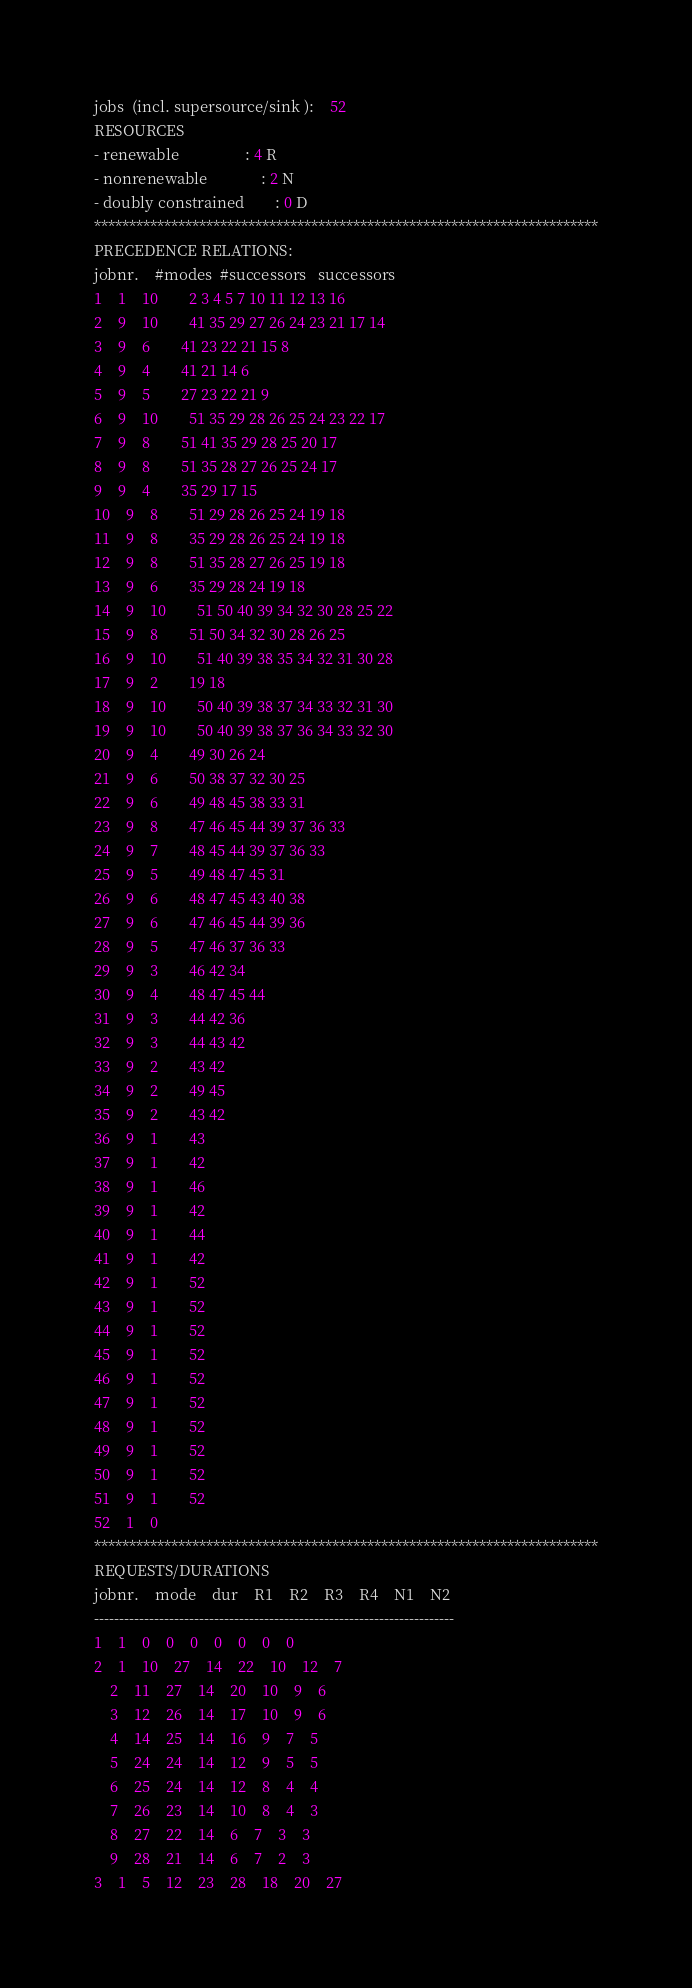<code> <loc_0><loc_0><loc_500><loc_500><_ObjectiveC_>jobs  (incl. supersource/sink ):	52
RESOURCES
- renewable                 : 4 R
- nonrenewable              : 2 N
- doubly constrained        : 0 D
************************************************************************
PRECEDENCE RELATIONS:
jobnr.    #modes  #successors   successors
1	1	10		2 3 4 5 7 10 11 12 13 16 
2	9	10		41 35 29 27 26 24 23 21 17 14 
3	9	6		41 23 22 21 15 8 
4	9	4		41 21 14 6 
5	9	5		27 23 22 21 9 
6	9	10		51 35 29 28 26 25 24 23 22 17 
7	9	8		51 41 35 29 28 25 20 17 
8	9	8		51 35 28 27 26 25 24 17 
9	9	4		35 29 17 15 
10	9	8		51 29 28 26 25 24 19 18 
11	9	8		35 29 28 26 25 24 19 18 
12	9	8		51 35 28 27 26 25 19 18 
13	9	6		35 29 28 24 19 18 
14	9	10		51 50 40 39 34 32 30 28 25 22 
15	9	8		51 50 34 32 30 28 26 25 
16	9	10		51 40 39 38 35 34 32 31 30 28 
17	9	2		19 18 
18	9	10		50 40 39 38 37 34 33 32 31 30 
19	9	10		50 40 39 38 37 36 34 33 32 30 
20	9	4		49 30 26 24 
21	9	6		50 38 37 32 30 25 
22	9	6		49 48 45 38 33 31 
23	9	8		47 46 45 44 39 37 36 33 
24	9	7		48 45 44 39 37 36 33 
25	9	5		49 48 47 45 31 
26	9	6		48 47 45 43 40 38 
27	9	6		47 46 45 44 39 36 
28	9	5		47 46 37 36 33 
29	9	3		46 42 34 
30	9	4		48 47 45 44 
31	9	3		44 42 36 
32	9	3		44 43 42 
33	9	2		43 42 
34	9	2		49 45 
35	9	2		43 42 
36	9	1		43 
37	9	1		42 
38	9	1		46 
39	9	1		42 
40	9	1		44 
41	9	1		42 
42	9	1		52 
43	9	1		52 
44	9	1		52 
45	9	1		52 
46	9	1		52 
47	9	1		52 
48	9	1		52 
49	9	1		52 
50	9	1		52 
51	9	1		52 
52	1	0		
************************************************************************
REQUESTS/DURATIONS
jobnr.	mode	dur	R1	R2	R3	R4	N1	N2	
------------------------------------------------------------------------
1	1	0	0	0	0	0	0	0	
2	1	10	27	14	22	10	12	7	
	2	11	27	14	20	10	9	6	
	3	12	26	14	17	10	9	6	
	4	14	25	14	16	9	7	5	
	5	24	24	14	12	9	5	5	
	6	25	24	14	12	8	4	4	
	7	26	23	14	10	8	4	3	
	8	27	22	14	6	7	3	3	
	9	28	21	14	6	7	2	3	
3	1	5	12	23	28	18	20	27	</code> 